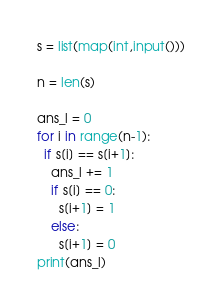Convert code to text. <code><loc_0><loc_0><loc_500><loc_500><_Python_>s = list(map(int,input()))

n = len(s)
 
ans_l = 0
for i in range(n-1):
  if s[i] == s[i+1]:
    ans_l += 1
    if s[i] == 0:
      s[i+1] = 1
    else:
      s[i+1] = 0
print(ans_l)
</code> 